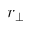<formula> <loc_0><loc_0><loc_500><loc_500>r _ { \perp }</formula> 